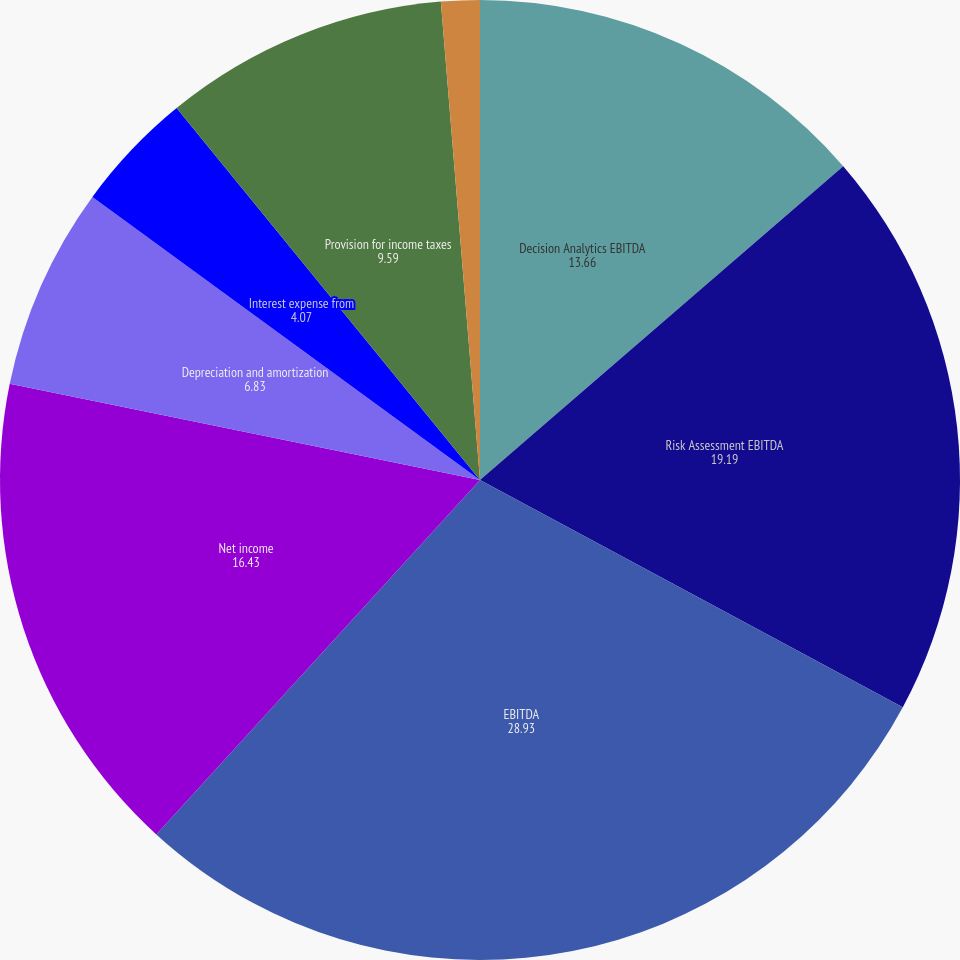Convert chart. <chart><loc_0><loc_0><loc_500><loc_500><pie_chart><fcel>Decision Analytics EBITDA<fcel>Risk Assessment EBITDA<fcel>EBITDA<fcel>Net income<fcel>Depreciation and amortization<fcel>Interest expense from<fcel>Provision for income taxes<fcel>Depreciation amortization<nl><fcel>13.66%<fcel>19.19%<fcel>28.93%<fcel>16.43%<fcel>6.83%<fcel>4.07%<fcel>9.59%<fcel>1.3%<nl></chart> 